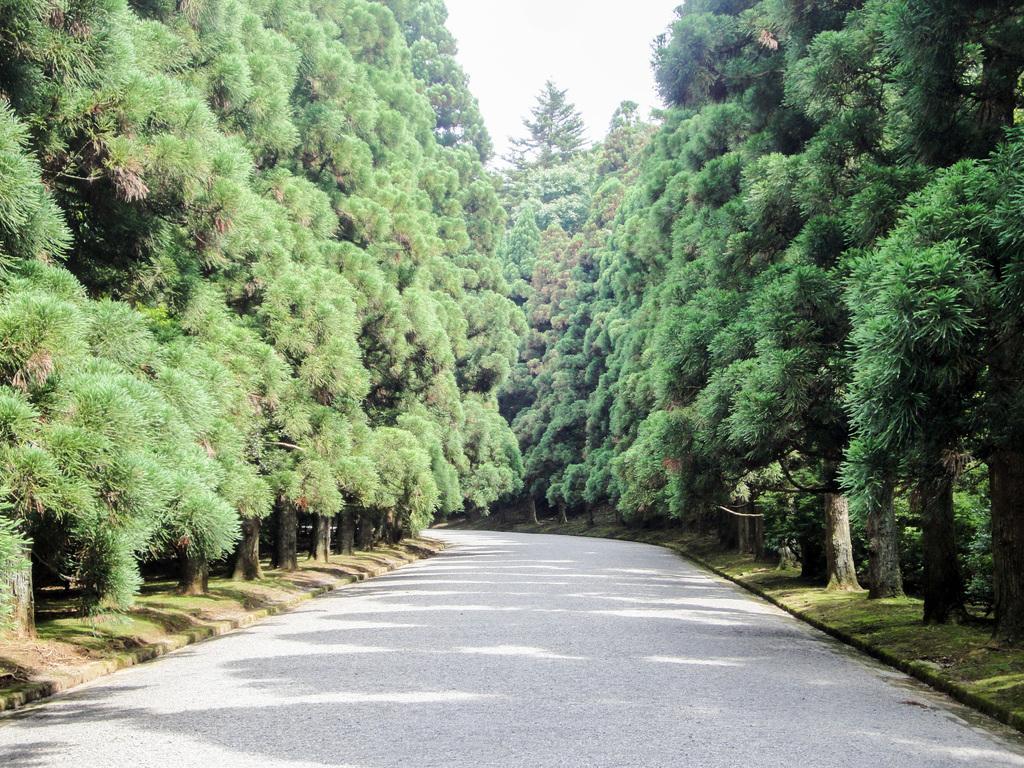Could you give a brief overview of what you see in this image? In this image I can see a road in the centre and on the both sides of the road I can see grass and number of trees. I can also see shadows on the ground and on the top side of this image I can see the sky. 